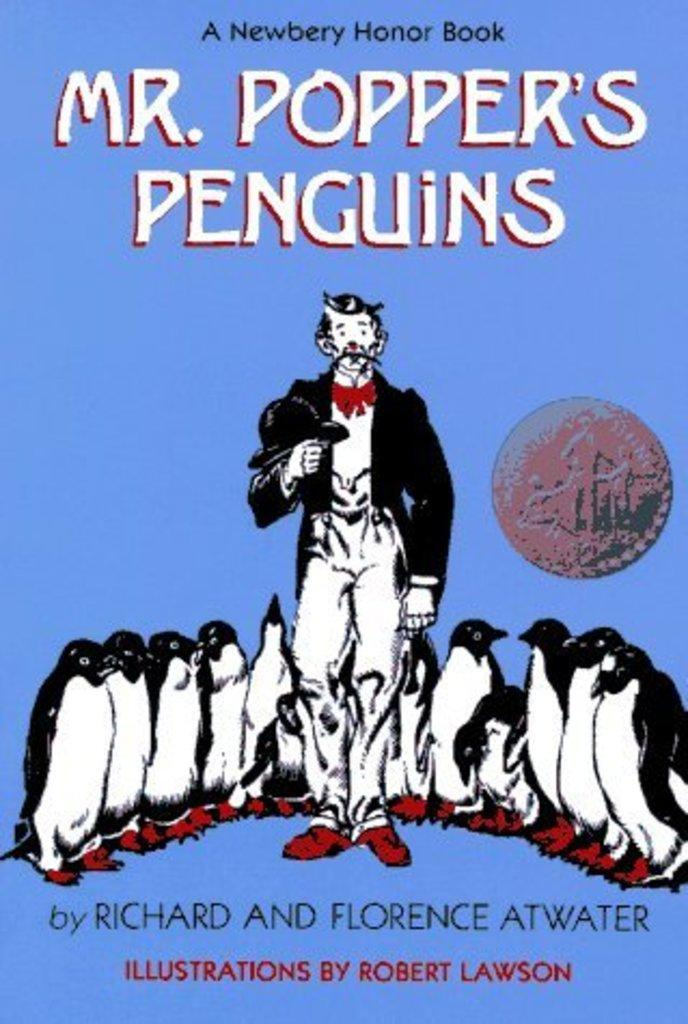Provide a one-sentence caption for the provided image. The front cover of the book "Mr. Popper's Penguins". 